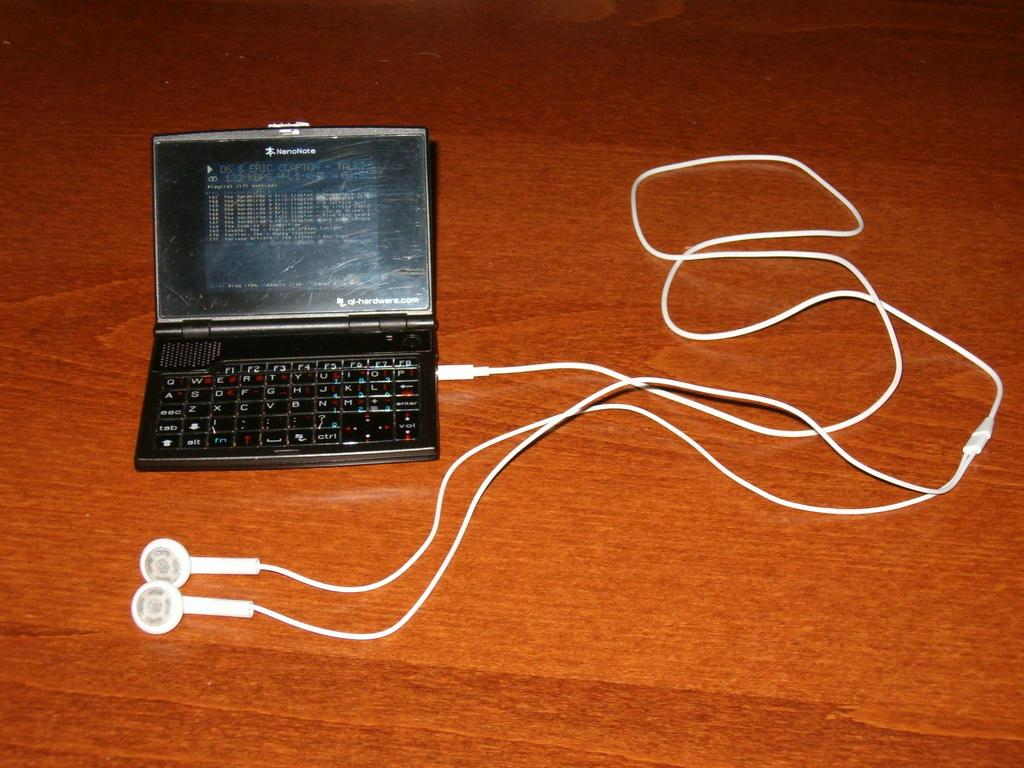Provide a one-sentence caption for the provided image. A NanoNote phone with a white cord coming out of it. 